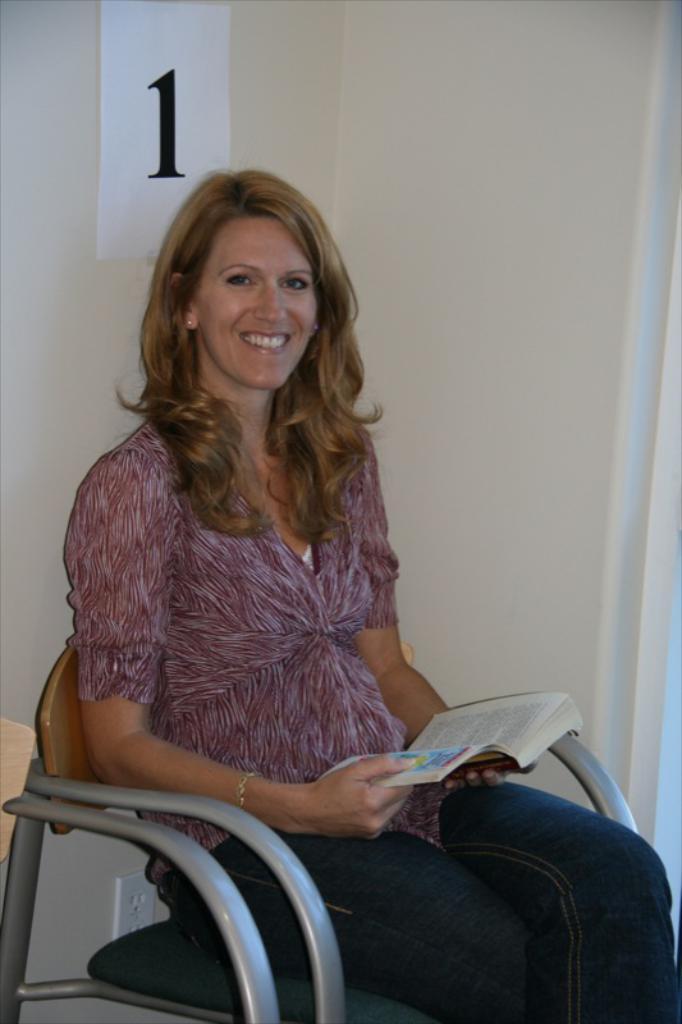Describe this image in one or two sentences. In this image there is a woman sitting on the chair, she is holding a book, there is a wall, there is a paper on the wall, there is a number on the paper, there is an object on the wall, there is an object towards the left of the image. 